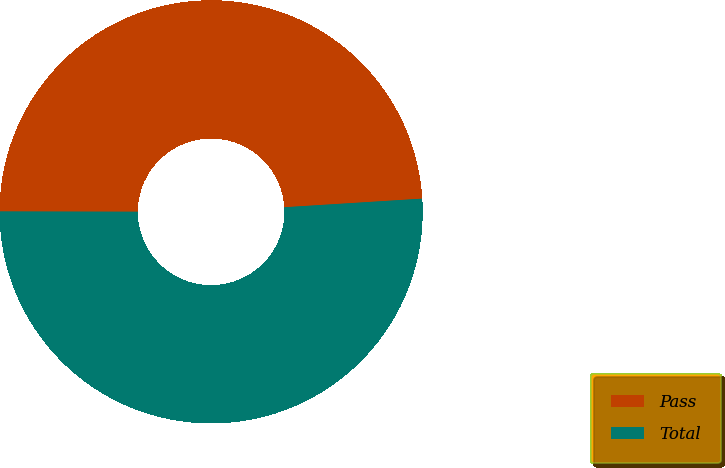Convert chart to OTSL. <chart><loc_0><loc_0><loc_500><loc_500><pie_chart><fcel>Pass<fcel>Total<nl><fcel>48.98%<fcel>51.02%<nl></chart> 